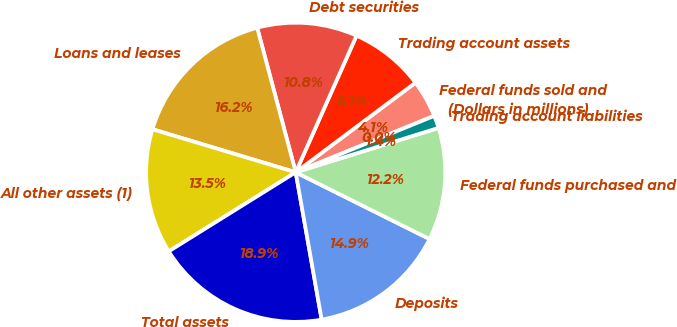Convert chart. <chart><loc_0><loc_0><loc_500><loc_500><pie_chart><fcel>(Dollars in millions)<fcel>Federal funds sold and<fcel>Trading account assets<fcel>Debt securities<fcel>Loans and leases<fcel>All other assets (1)<fcel>Total assets<fcel>Deposits<fcel>Federal funds purchased and<fcel>Trading account liabilities<nl><fcel>0.01%<fcel>4.06%<fcel>8.11%<fcel>10.81%<fcel>16.21%<fcel>13.51%<fcel>18.91%<fcel>14.86%<fcel>12.16%<fcel>1.36%<nl></chart> 